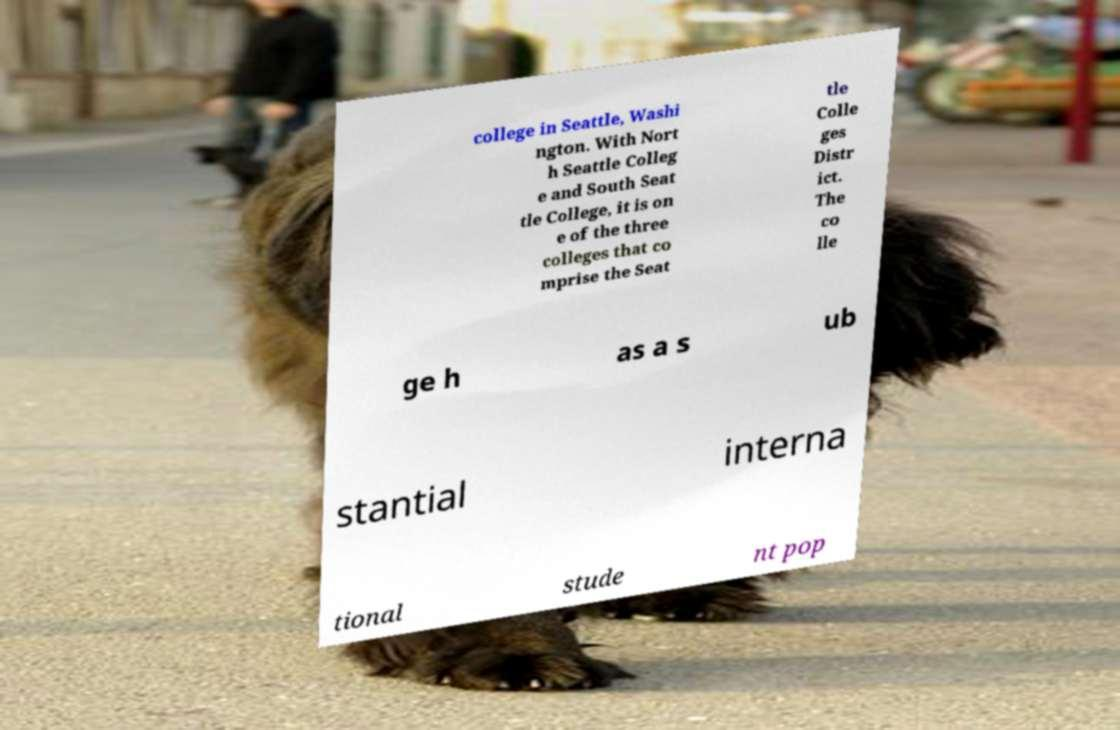Please read and relay the text visible in this image. What does it say? college in Seattle, Washi ngton. With Nort h Seattle Colleg e and South Seat tle College, it is on e of the three colleges that co mprise the Seat tle Colle ges Distr ict. The co lle ge h as a s ub stantial interna tional stude nt pop 